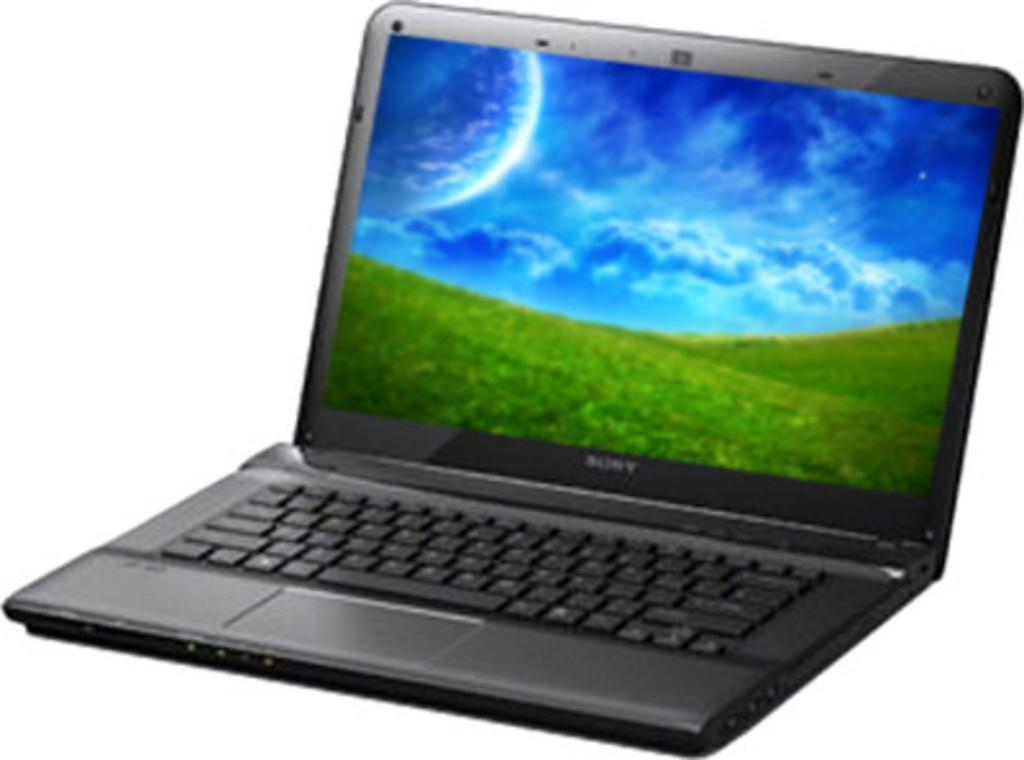<image>
Provide a brief description of the given image. A Sony laptop displays a field with a large planet in the sky. 